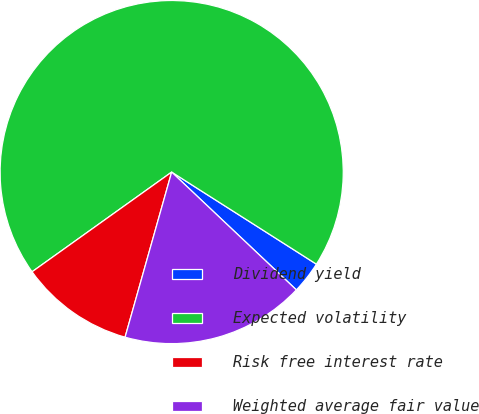Convert chart to OTSL. <chart><loc_0><loc_0><loc_500><loc_500><pie_chart><fcel>Dividend yield<fcel>Expected volatility<fcel>Risk free interest rate<fcel>Weighted average fair value<nl><fcel>3.03%<fcel>68.89%<fcel>10.75%<fcel>17.33%<nl></chart> 